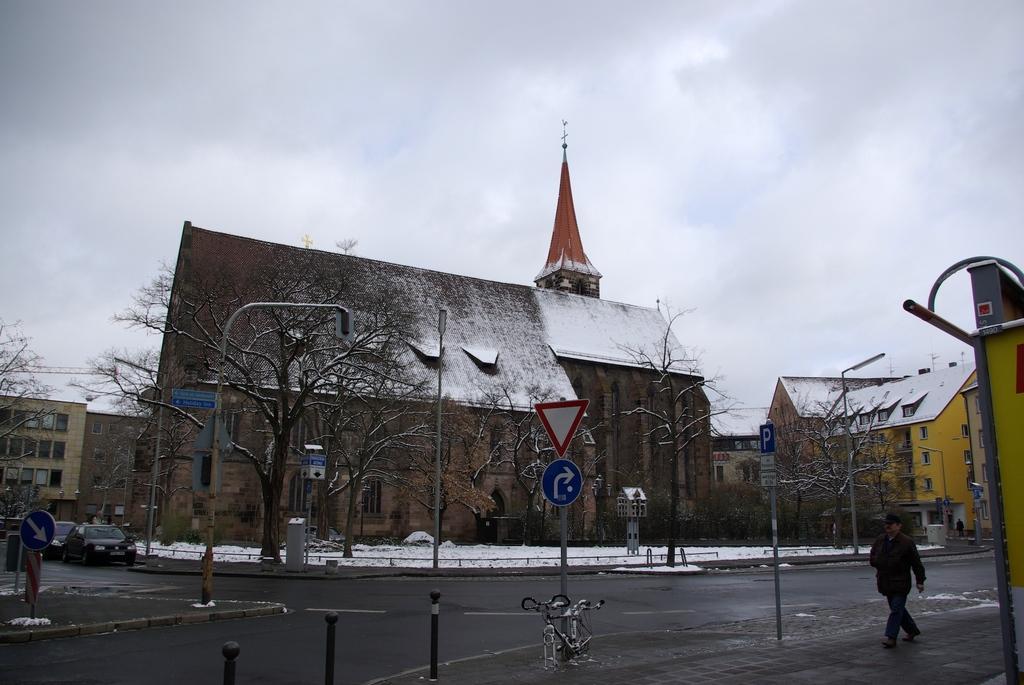Can you describe this image briefly? In this picture we can see many buildings. At the bottom we can see bicycle near to sign board. At the bottom right corner there is a man who is walking on the street. On the left we can see cars on the road. At the top we can see sky and clouds. In front of the building we can see trees, snow, fencing and street light. 